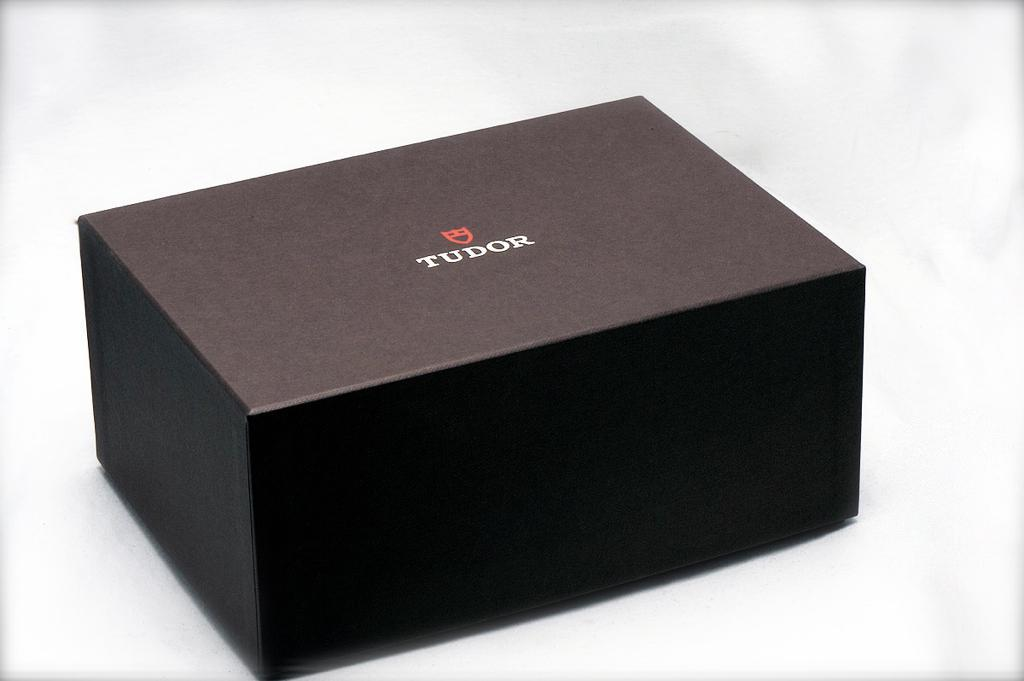<image>
Summarize the visual content of the image. A small black box with the word Tudor on the lid. 